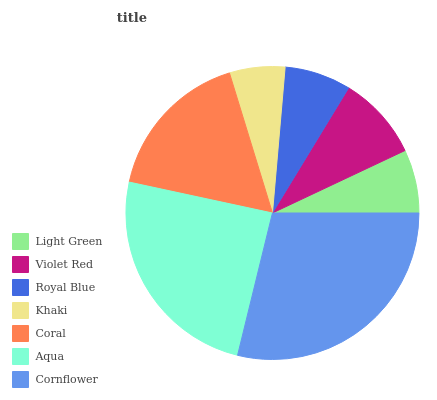Is Khaki the minimum?
Answer yes or no. Yes. Is Cornflower the maximum?
Answer yes or no. Yes. Is Violet Red the minimum?
Answer yes or no. No. Is Violet Red the maximum?
Answer yes or no. No. Is Violet Red greater than Light Green?
Answer yes or no. Yes. Is Light Green less than Violet Red?
Answer yes or no. Yes. Is Light Green greater than Violet Red?
Answer yes or no. No. Is Violet Red less than Light Green?
Answer yes or no. No. Is Violet Red the high median?
Answer yes or no. Yes. Is Violet Red the low median?
Answer yes or no. Yes. Is Khaki the high median?
Answer yes or no. No. Is Coral the low median?
Answer yes or no. No. 